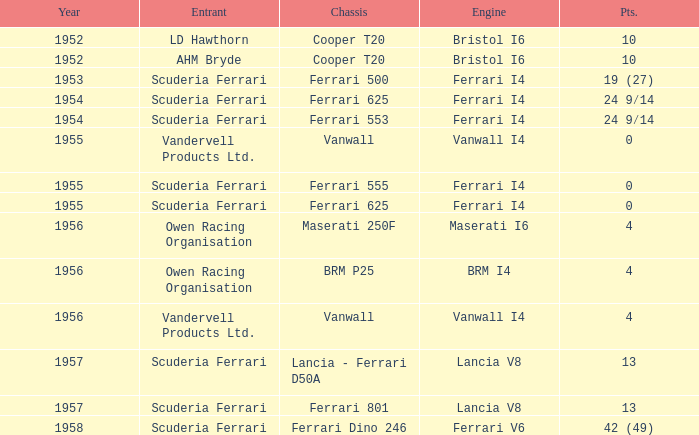How many points were scored when the Chassis is BRM p25? 4.0. 